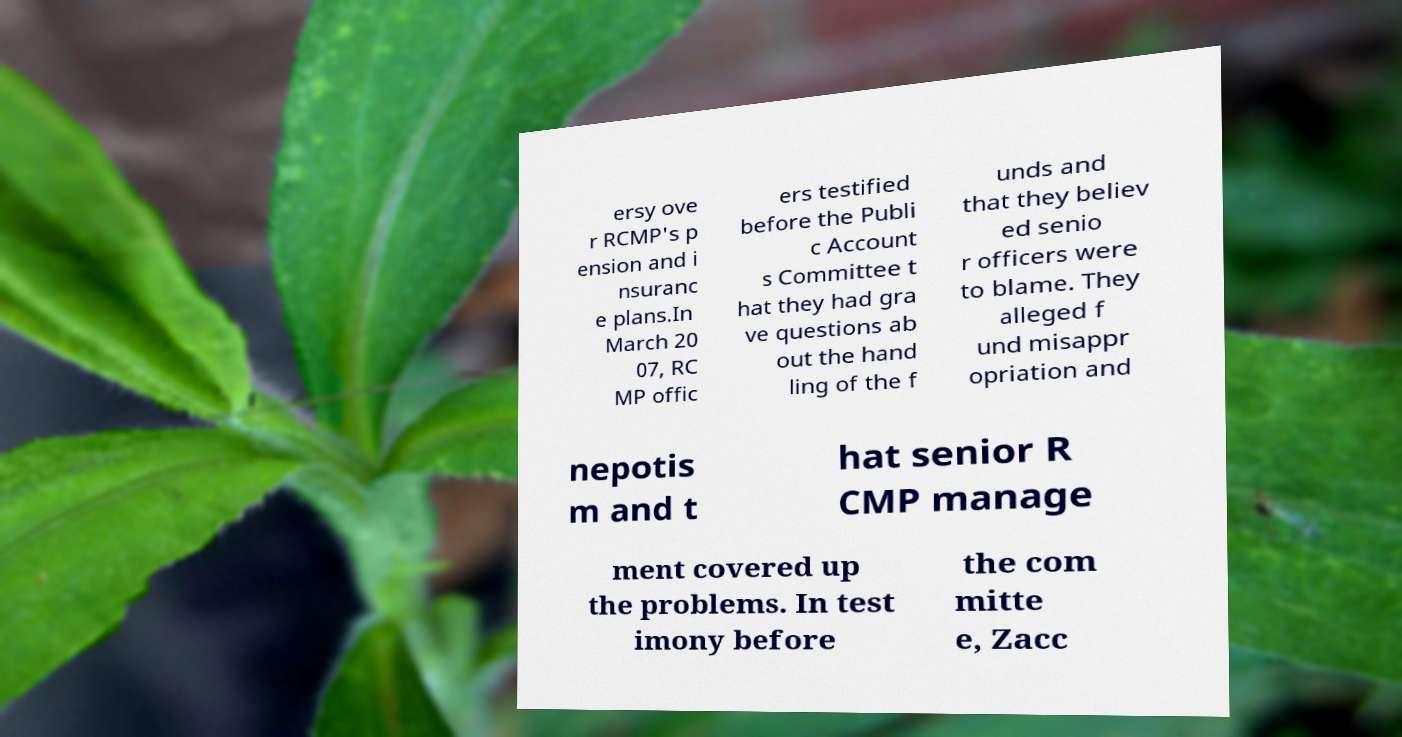Could you extract and type out the text from this image? ersy ove r RCMP's p ension and i nsuranc e plans.In March 20 07, RC MP offic ers testified before the Publi c Account s Committee t hat they had gra ve questions ab out the hand ling of the f unds and that they believ ed senio r officers were to blame. They alleged f und misappr opriation and nepotis m and t hat senior R CMP manage ment covered up the problems. In test imony before the com mitte e, Zacc 